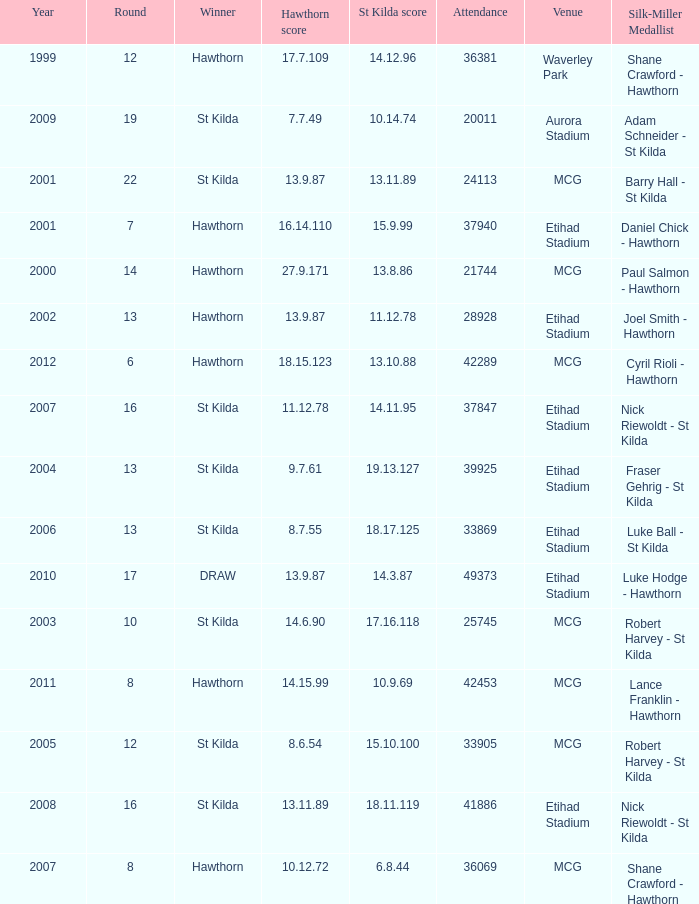Write the full table. {'header': ['Year', 'Round', 'Winner', 'Hawthorn score', 'St Kilda score', 'Attendance', 'Venue', 'Silk-Miller Medallist'], 'rows': [['1999', '12', 'Hawthorn', '17.7.109', '14.12.96', '36381', 'Waverley Park', 'Shane Crawford - Hawthorn'], ['2009', '19', 'St Kilda', '7.7.49', '10.14.74', '20011', 'Aurora Stadium', 'Adam Schneider - St Kilda'], ['2001', '22', 'St Kilda', '13.9.87', '13.11.89', '24113', 'MCG', 'Barry Hall - St Kilda'], ['2001', '7', 'Hawthorn', '16.14.110', '15.9.99', '37940', 'Etihad Stadium', 'Daniel Chick - Hawthorn'], ['2000', '14', 'Hawthorn', '27.9.171', '13.8.86', '21744', 'MCG', 'Paul Salmon - Hawthorn'], ['2002', '13', 'Hawthorn', '13.9.87', '11.12.78', '28928', 'Etihad Stadium', 'Joel Smith - Hawthorn'], ['2012', '6', 'Hawthorn', '18.15.123', '13.10.88', '42289', 'MCG', 'Cyril Rioli - Hawthorn'], ['2007', '16', 'St Kilda', '11.12.78', '14.11.95', '37847', 'Etihad Stadium', 'Nick Riewoldt - St Kilda'], ['2004', '13', 'St Kilda', '9.7.61', '19.13.127', '39925', 'Etihad Stadium', 'Fraser Gehrig - St Kilda'], ['2006', '13', 'St Kilda', '8.7.55', '18.17.125', '33869', 'Etihad Stadium', 'Luke Ball - St Kilda'], ['2010', '17', 'DRAW', '13.9.87', '14.3.87', '49373', 'Etihad Stadium', 'Luke Hodge - Hawthorn'], ['2003', '10', 'St Kilda', '14.6.90', '17.16.118', '25745', 'MCG', 'Robert Harvey - St Kilda'], ['2011', '8', 'Hawthorn', '14.15.99', '10.9.69', '42453', 'MCG', 'Lance Franklin - Hawthorn'], ['2005', '12', 'St Kilda', '8.6.54', '15.10.100', '33905', 'MCG', 'Robert Harvey - St Kilda'], ['2008', '16', 'St Kilda', '13.11.89', '18.11.119', '41886', 'Etihad Stadium', 'Nick Riewoldt - St Kilda'], ['2007', '8', 'Hawthorn', '10.12.72', '6.8.44', '36069', 'MCG', 'Shane Crawford - Hawthorn']]} What is the attendance when the st kilda score is 13.10.88? 42289.0. 